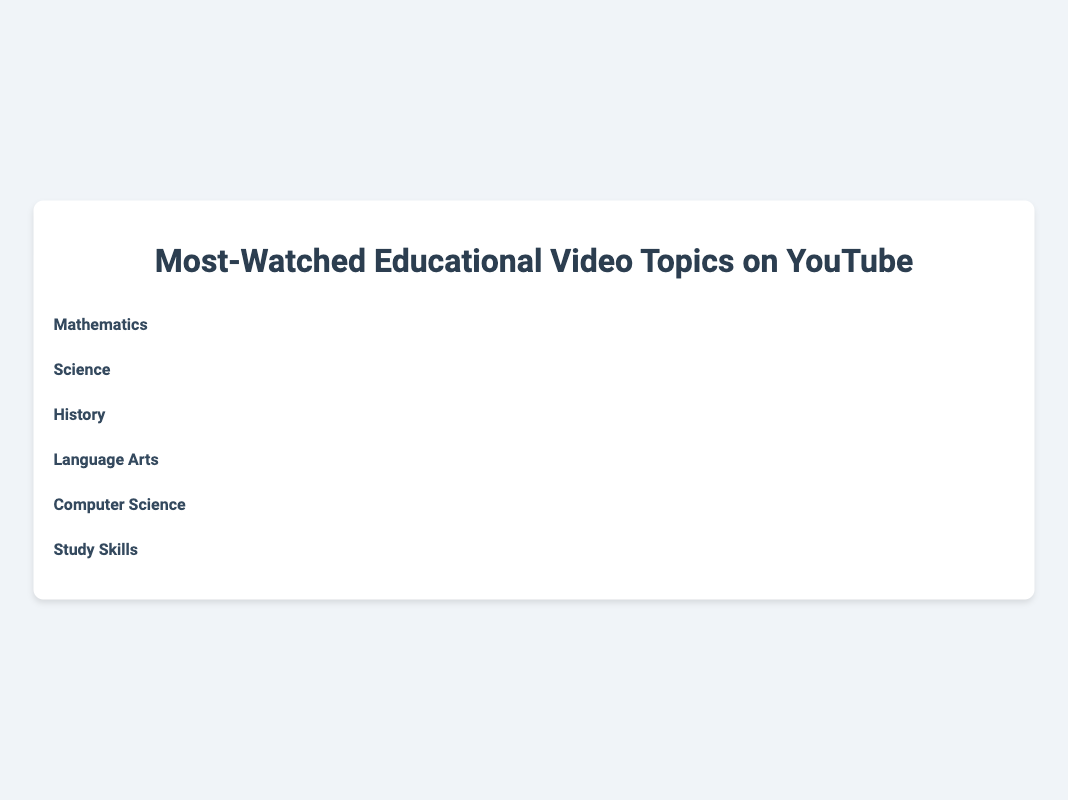what is the title of the plot? The title of the plot is at the top center of the figure. It reads "Most-Watched Educational Video Topics on YouTube."
Answer: Most-Watched Educational Video Topics on YouTube Which subject has the highest number of views? Each subject's views are shown numerically on the right side of the plot. The highest number is 600K, associated with "Study Skills."
Answer: Study Skills Can you list all the icons used in the plot? Each subject has a distinct icon which represents it visually. The six icons are a calculator, microscope, book, pencil, laptop, and graduation cap.
Answer: calculator, microscope, book, pencil, laptop, graduation cap What is the total number of views for Science and Language Arts combined? The views for Science and Language Arts are 450K and 350K respectively. Summing these values gives 450 + 350 = 800K.
Answer: 800K How many more views does Mathematics have than History? Mathematics has 500K views and History has 300K views. The difference is 500 - 300 = 200K.
Answer: 200K Which two subject areas have the closest number of views? By comparing the numbers, Computer Science (400K) and Science (450K) have the smallest difference, which is 450 - 400 = 50K.
Answer: Computer Science and Science What is the average (mean) number of views across all the subject areas? Sum all the views and divide by the number of subjects. (500K + 450K + 300K + 350K + 400K + 600K) / 6 = 2,600K / 6 = approximately 433.33K.
Answer: 433.33K How are the subjects ordered in the plot? The subjects are ordered by the number of views in ascending order, starting from History and ending with Study Skills.
Answer: Ascending order of views What percentage of total views does Mathematics account for? Total views are 2,600K. Mathematics has 500K views. (500K / 2,600K) * 100 = approximately 19.23%.
Answer: 19.23% Which subject has fewer views than Computer Science but more than Language Arts? Computer Science has 400K views; Language Arts has 350K views. The subject in between these is Science with 450K views.
Answer: Science 